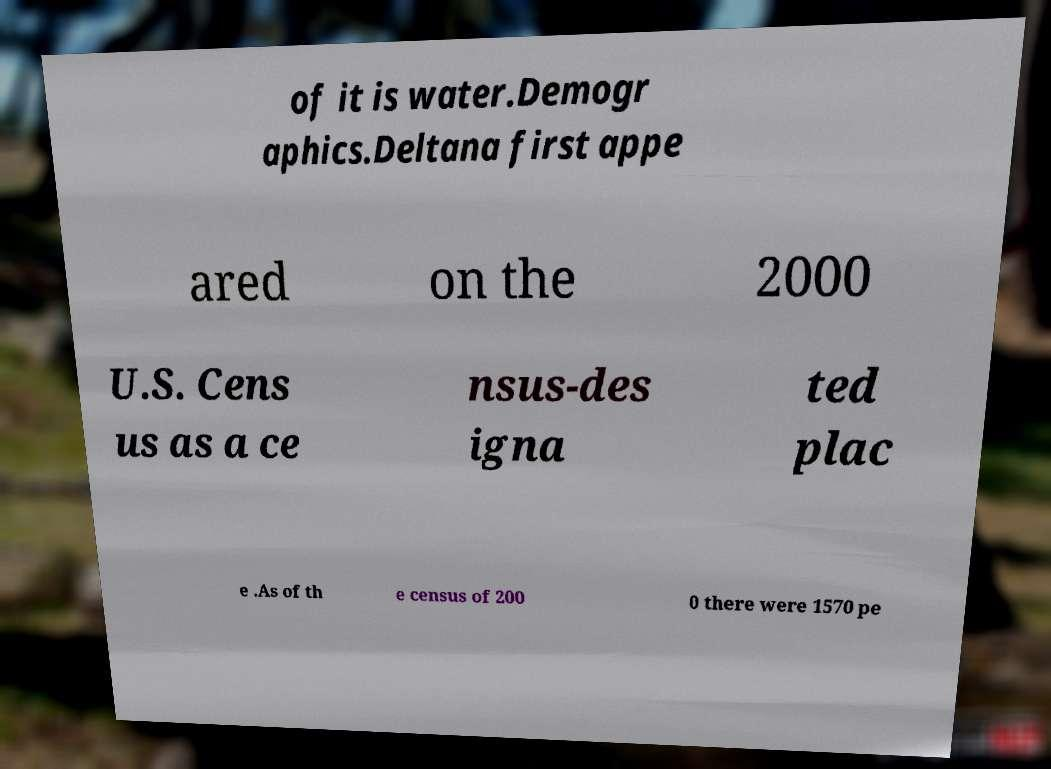Could you assist in decoding the text presented in this image and type it out clearly? of it is water.Demogr aphics.Deltana first appe ared on the 2000 U.S. Cens us as a ce nsus-des igna ted plac e .As of th e census of 200 0 there were 1570 pe 